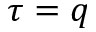<formula> <loc_0><loc_0><loc_500><loc_500>\tau = q</formula> 